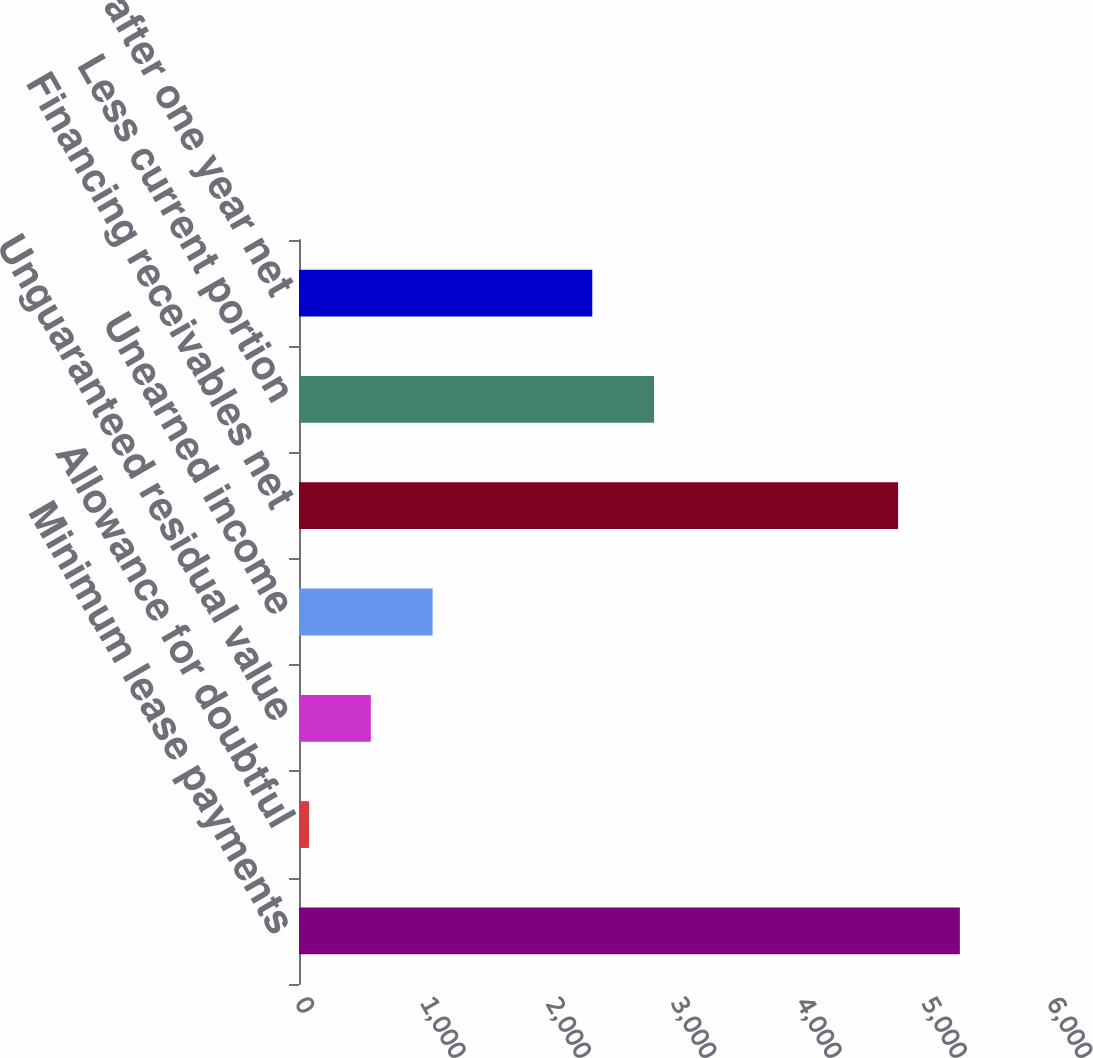Convert chart to OTSL. <chart><loc_0><loc_0><loc_500><loc_500><bar_chart><fcel>Minimum lease payments<fcel>Allowance for doubtful<fcel>Unguaranteed residual value<fcel>Unearned income<fcel>Financing receivables net<fcel>Less current portion<fcel>Amounts due after one year net<nl><fcel>5273<fcel>80<fcel>573<fcel>1066<fcel>4780<fcel>2833<fcel>2340<nl></chart> 